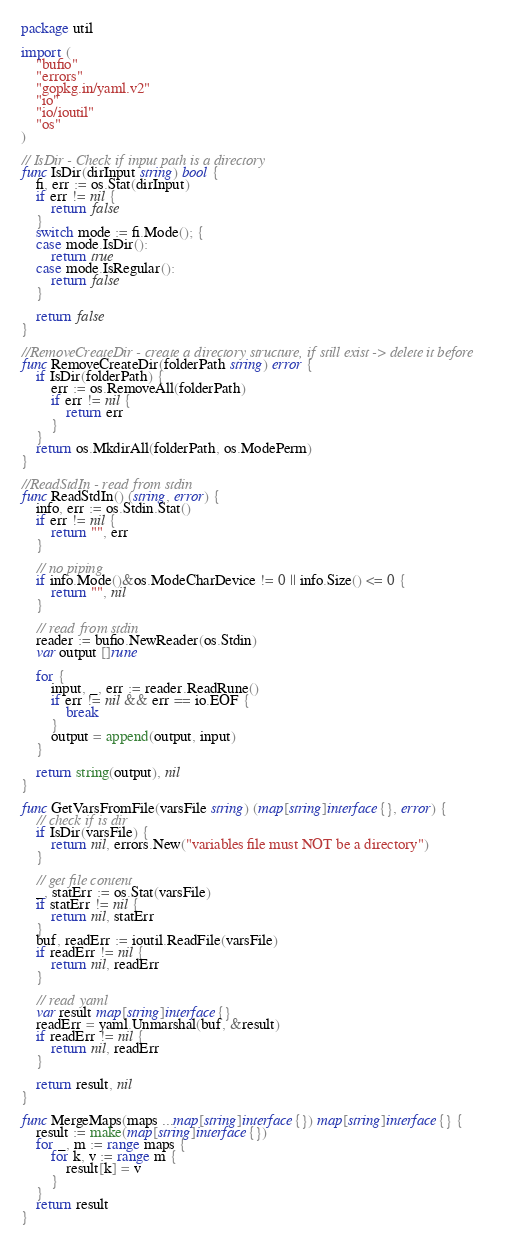Convert code to text. <code><loc_0><loc_0><loc_500><loc_500><_Go_>package util

import (
	"bufio"
	"errors"
	"gopkg.in/yaml.v2"
	"io"
	"io/ioutil"
	"os"
)

// IsDir - Check if input path is a directory
func IsDir(dirInput string) bool {
	fi, err := os.Stat(dirInput)
	if err != nil {
		return false
	}
	switch mode := fi.Mode(); {
	case mode.IsDir():
		return true
	case mode.IsRegular():
		return false
	}

	return false
}

//RemoveCreateDir - create a directory structure, if still exist -> delete it before
func RemoveCreateDir(folderPath string) error {
	if IsDir(folderPath) {
		err := os.RemoveAll(folderPath)
		if err != nil {
			return err
		}
	}
	return os.MkdirAll(folderPath, os.ModePerm)
}

//ReadStdIn - read from stdin
func ReadStdIn() (string, error) {
	info, err := os.Stdin.Stat()
	if err != nil {
		return "", err
	}

	// no piping
	if info.Mode()&os.ModeCharDevice != 0 || info.Size() <= 0 {
		return "", nil
	}

	// read from stdin
	reader := bufio.NewReader(os.Stdin)
	var output []rune

	for {
		input, _, err := reader.ReadRune()
		if err != nil && err == io.EOF {
			break
		}
		output = append(output, input)
	}

	return string(output), nil
}

func GetVarsFromFile(varsFile string) (map[string]interface{}, error) {
	// check if is dir
	if IsDir(varsFile) {
		return nil, errors.New("variables file must NOT be a directory")
	}

	// get file content
	_, statErr := os.Stat(varsFile)
	if statErr != nil {
		return nil, statErr
	}
	buf, readErr := ioutil.ReadFile(varsFile)
	if readErr != nil {
		return nil, readErr
	}

	// read yaml
	var result map[string]interface{}
	readErr = yaml.Unmarshal(buf, &result)
	if readErr != nil {
		return nil, readErr
	}

	return result, nil
}

func MergeMaps(maps ...map[string]interface{}) map[string]interface{} {
	result := make(map[string]interface{})
	for _, m := range maps {
		for k, v := range m {
			result[k] = v
		}
	}
	return result
}
</code> 